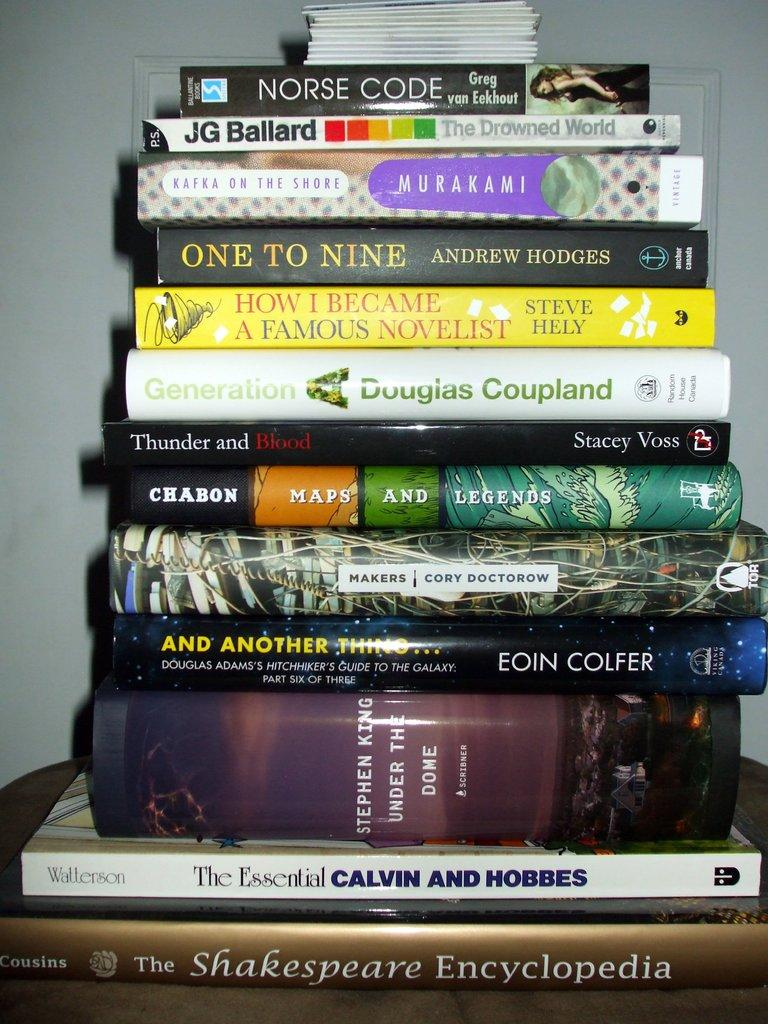<image>
Present a compact description of the photo's key features. A stack of books with one titled "Norse Code" on top 